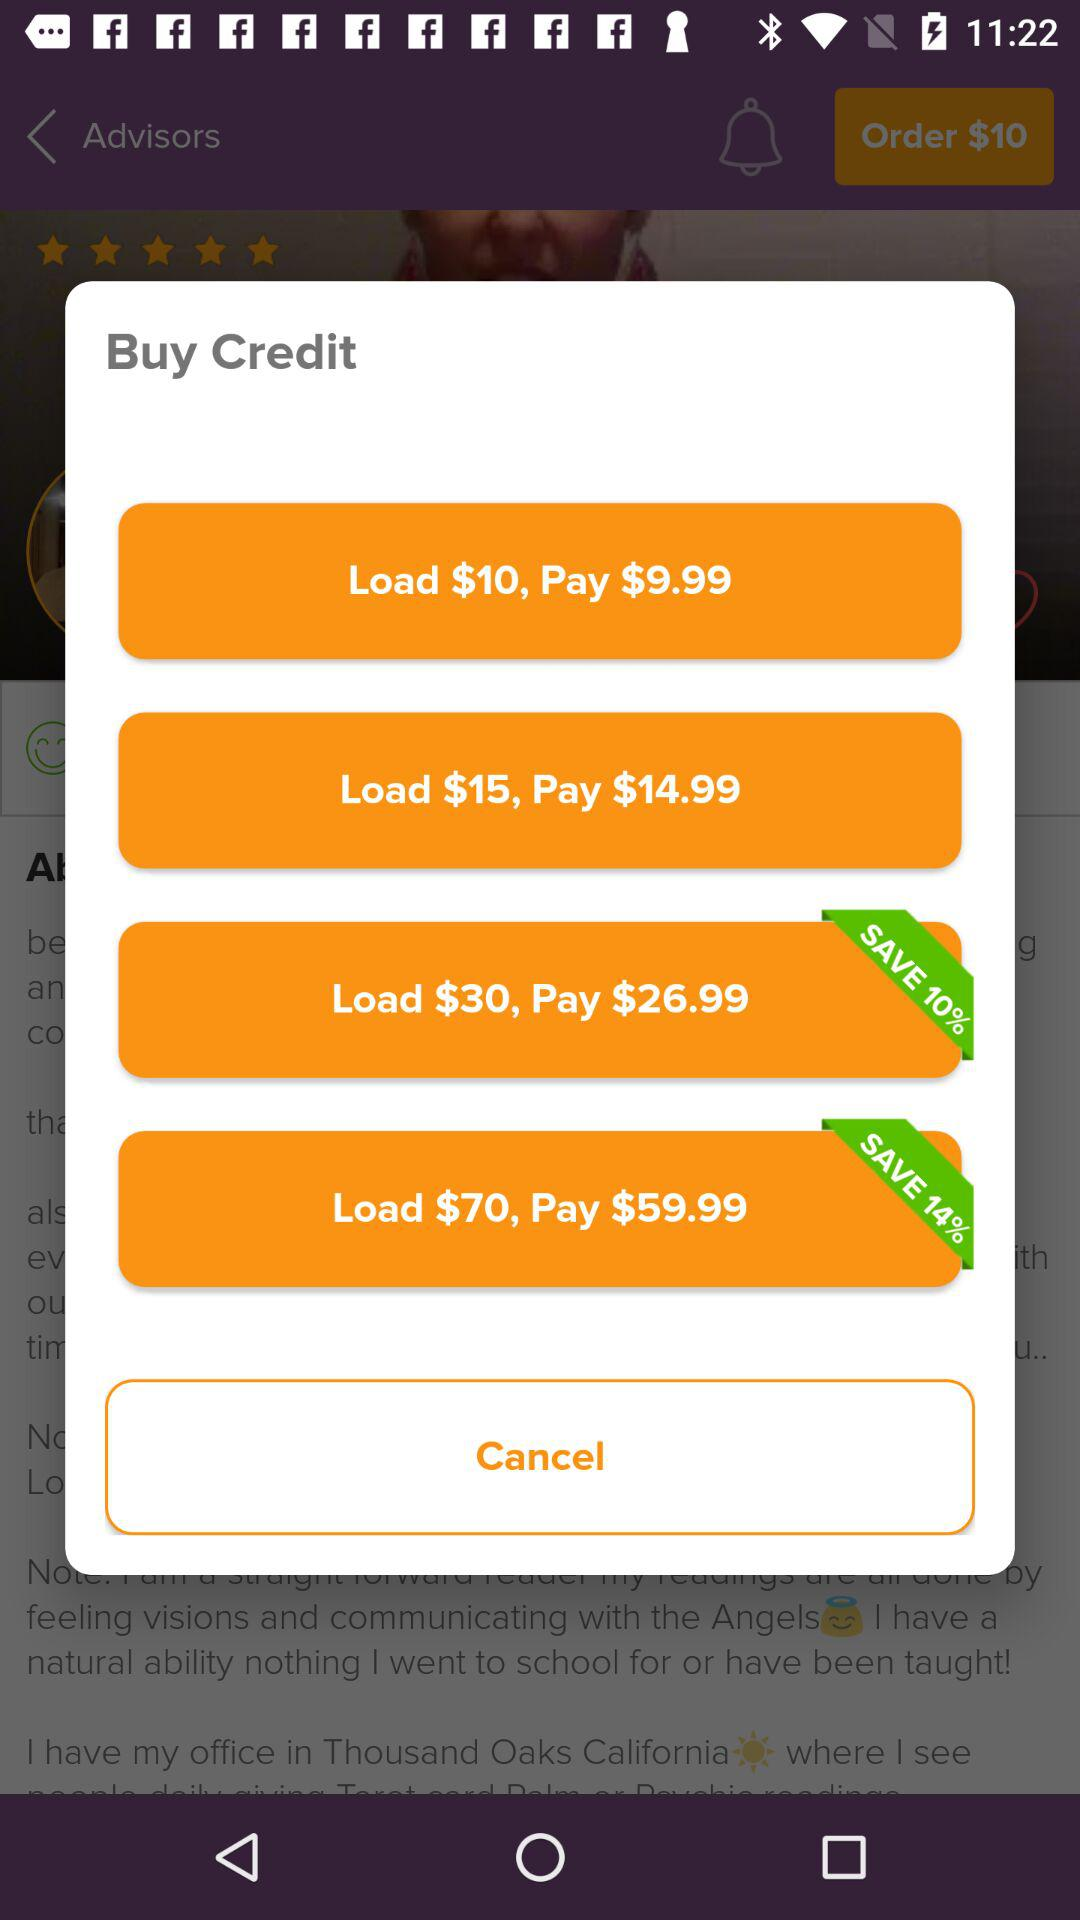How many dollars can be loaded by paying $26.99? By paying $26.99, $30 can be loaded. 